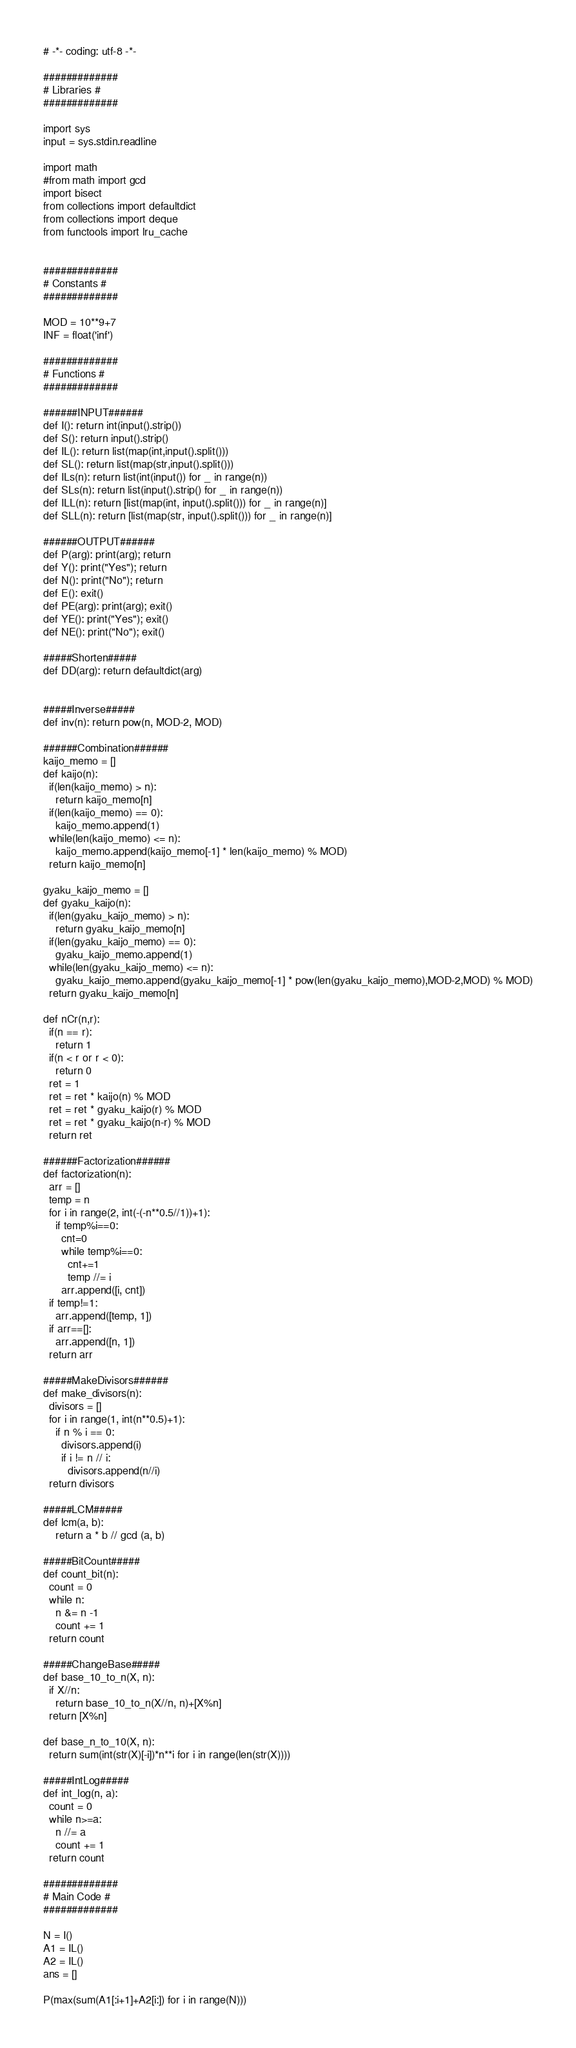<code> <loc_0><loc_0><loc_500><loc_500><_Python_># -*- coding: utf-8 -*-

#############
# Libraries #
#############

import sys
input = sys.stdin.readline

import math
#from math import gcd
import bisect
from collections import defaultdict
from collections import deque
from functools import lru_cache


#############
# Constants #
#############

MOD = 10**9+7
INF = float('inf')

#############
# Functions #
#############

######INPUT######
def I(): return int(input().strip())
def S(): return input().strip()
def IL(): return list(map(int,input().split()))
def SL(): return list(map(str,input().split()))
def ILs(n): return list(int(input()) for _ in range(n))
def SLs(n): return list(input().strip() for _ in range(n))
def ILL(n): return [list(map(int, input().split())) for _ in range(n)]
def SLL(n): return [list(map(str, input().split())) for _ in range(n)]

######OUTPUT######
def P(arg): print(arg); return
def Y(): print("Yes"); return
def N(): print("No"); return
def E(): exit()
def PE(arg): print(arg); exit()
def YE(): print("Yes"); exit()
def NE(): print("No"); exit()

#####Shorten#####
def DD(arg): return defaultdict(arg)


#####Inverse#####
def inv(n): return pow(n, MOD-2, MOD)

######Combination######
kaijo_memo = []
def kaijo(n):
  if(len(kaijo_memo) > n):
    return kaijo_memo[n]
  if(len(kaijo_memo) == 0):
    kaijo_memo.append(1)
  while(len(kaijo_memo) <= n):
    kaijo_memo.append(kaijo_memo[-1] * len(kaijo_memo) % MOD)
  return kaijo_memo[n]

gyaku_kaijo_memo = []
def gyaku_kaijo(n):
  if(len(gyaku_kaijo_memo) > n):
    return gyaku_kaijo_memo[n]
  if(len(gyaku_kaijo_memo) == 0):
    gyaku_kaijo_memo.append(1)
  while(len(gyaku_kaijo_memo) <= n):
    gyaku_kaijo_memo.append(gyaku_kaijo_memo[-1] * pow(len(gyaku_kaijo_memo),MOD-2,MOD) % MOD)
  return gyaku_kaijo_memo[n]

def nCr(n,r):
  if(n == r):
    return 1
  if(n < r or r < 0):
    return 0
  ret = 1
  ret = ret * kaijo(n) % MOD
  ret = ret * gyaku_kaijo(r) % MOD
  ret = ret * gyaku_kaijo(n-r) % MOD
  return ret

######Factorization######
def factorization(n):
  arr = []
  temp = n
  for i in range(2, int(-(-n**0.5//1))+1):
    if temp%i==0:
      cnt=0
      while temp%i==0: 
        cnt+=1 
        temp //= i
      arr.append([i, cnt])
  if temp!=1:
    arr.append([temp, 1])
  if arr==[]:
    arr.append([n, 1])
  return arr

#####MakeDivisors######
def make_divisors(n):
  divisors = []
  for i in range(1, int(n**0.5)+1):
    if n % i == 0:
      divisors.append(i)
      if i != n // i: 
        divisors.append(n//i)
  return divisors

#####LCM#####
def lcm(a, b):
    return a * b // gcd (a, b)

#####BitCount#####
def count_bit(n):
  count = 0
  while n:
    n &= n -1
    count += 1
  return count

#####ChangeBase#####
def base_10_to_n(X, n):
  if X//n:
    return base_10_to_n(X//n, n)+[X%n]
  return [X%n]

def base_n_to_10(X, n):
  return sum(int(str(X)[-i])*n**i for i in range(len(str(X))))

#####IntLog#####
def int_log(n, a):
  count = 0
  while n>=a:
    n //= a
    count += 1
  return count

#############
# Main Code #
#############

N = I()
A1 = IL()
A2 = IL()
ans = []

P(max(sum(A1[:i+1]+A2[i:]) for i in range(N)))</code> 